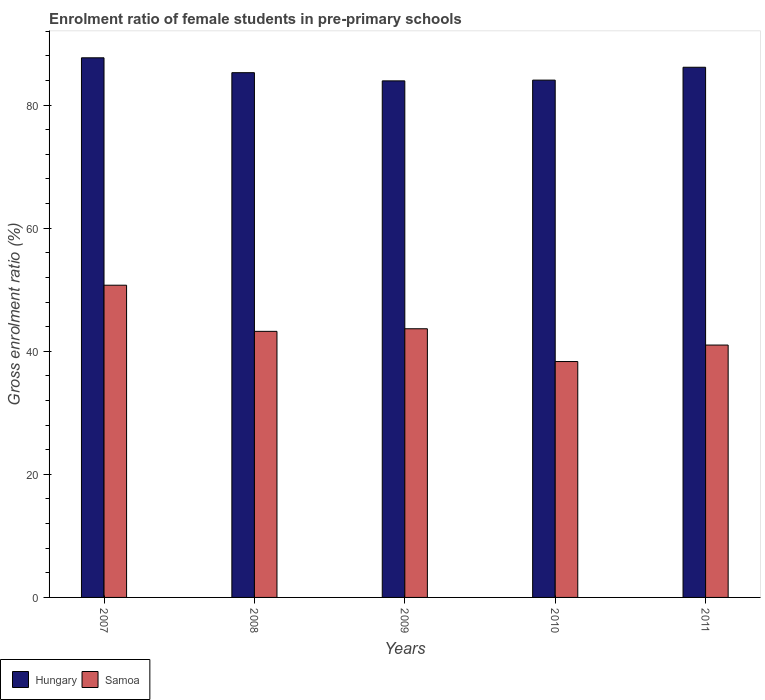How many different coloured bars are there?
Provide a short and direct response. 2. Are the number of bars on each tick of the X-axis equal?
Provide a succinct answer. Yes. In how many cases, is the number of bars for a given year not equal to the number of legend labels?
Ensure brevity in your answer.  0. What is the enrolment ratio of female students in pre-primary schools in Hungary in 2009?
Provide a short and direct response. 83.95. Across all years, what is the maximum enrolment ratio of female students in pre-primary schools in Hungary?
Your answer should be compact. 87.69. Across all years, what is the minimum enrolment ratio of female students in pre-primary schools in Samoa?
Your answer should be very brief. 38.33. What is the total enrolment ratio of female students in pre-primary schools in Hungary in the graph?
Your answer should be very brief. 427.15. What is the difference between the enrolment ratio of female students in pre-primary schools in Hungary in 2007 and that in 2009?
Your response must be concise. 3.75. What is the difference between the enrolment ratio of female students in pre-primary schools in Hungary in 2008 and the enrolment ratio of female students in pre-primary schools in Samoa in 2009?
Offer a terse response. 41.62. What is the average enrolment ratio of female students in pre-primary schools in Hungary per year?
Your answer should be very brief. 85.43. In the year 2011, what is the difference between the enrolment ratio of female students in pre-primary schools in Samoa and enrolment ratio of female students in pre-primary schools in Hungary?
Give a very brief answer. -45.15. What is the ratio of the enrolment ratio of female students in pre-primary schools in Samoa in 2008 to that in 2009?
Make the answer very short. 0.99. What is the difference between the highest and the second highest enrolment ratio of female students in pre-primary schools in Hungary?
Your response must be concise. 1.53. What is the difference between the highest and the lowest enrolment ratio of female students in pre-primary schools in Hungary?
Offer a very short reply. 3.75. What does the 2nd bar from the left in 2010 represents?
Offer a very short reply. Samoa. What does the 2nd bar from the right in 2011 represents?
Your answer should be compact. Hungary. How many bars are there?
Your answer should be very brief. 10. What is the difference between two consecutive major ticks on the Y-axis?
Provide a short and direct response. 20. Does the graph contain any zero values?
Offer a very short reply. No. Does the graph contain grids?
Your answer should be very brief. No. Where does the legend appear in the graph?
Provide a short and direct response. Bottom left. How many legend labels are there?
Provide a succinct answer. 2. How are the legend labels stacked?
Give a very brief answer. Horizontal. What is the title of the graph?
Provide a succinct answer. Enrolment ratio of female students in pre-primary schools. Does "Korea (Republic)" appear as one of the legend labels in the graph?
Your answer should be compact. No. What is the label or title of the X-axis?
Your response must be concise. Years. What is the label or title of the Y-axis?
Provide a succinct answer. Gross enrolment ratio (%). What is the Gross enrolment ratio (%) in Hungary in 2007?
Offer a terse response. 87.69. What is the Gross enrolment ratio (%) of Samoa in 2007?
Ensure brevity in your answer.  50.74. What is the Gross enrolment ratio (%) of Hungary in 2008?
Provide a succinct answer. 85.28. What is the Gross enrolment ratio (%) in Samoa in 2008?
Provide a short and direct response. 43.24. What is the Gross enrolment ratio (%) of Hungary in 2009?
Provide a succinct answer. 83.95. What is the Gross enrolment ratio (%) of Samoa in 2009?
Provide a short and direct response. 43.66. What is the Gross enrolment ratio (%) of Hungary in 2010?
Offer a very short reply. 84.07. What is the Gross enrolment ratio (%) in Samoa in 2010?
Offer a very short reply. 38.33. What is the Gross enrolment ratio (%) of Hungary in 2011?
Give a very brief answer. 86.16. What is the Gross enrolment ratio (%) of Samoa in 2011?
Offer a terse response. 41.01. Across all years, what is the maximum Gross enrolment ratio (%) of Hungary?
Make the answer very short. 87.69. Across all years, what is the maximum Gross enrolment ratio (%) in Samoa?
Your answer should be very brief. 50.74. Across all years, what is the minimum Gross enrolment ratio (%) of Hungary?
Provide a short and direct response. 83.95. Across all years, what is the minimum Gross enrolment ratio (%) in Samoa?
Offer a very short reply. 38.33. What is the total Gross enrolment ratio (%) of Hungary in the graph?
Give a very brief answer. 427.15. What is the total Gross enrolment ratio (%) in Samoa in the graph?
Offer a very short reply. 216.98. What is the difference between the Gross enrolment ratio (%) of Hungary in 2007 and that in 2008?
Your answer should be very brief. 2.42. What is the difference between the Gross enrolment ratio (%) of Samoa in 2007 and that in 2008?
Ensure brevity in your answer.  7.5. What is the difference between the Gross enrolment ratio (%) of Hungary in 2007 and that in 2009?
Your answer should be compact. 3.75. What is the difference between the Gross enrolment ratio (%) in Samoa in 2007 and that in 2009?
Offer a very short reply. 7.08. What is the difference between the Gross enrolment ratio (%) in Hungary in 2007 and that in 2010?
Your answer should be very brief. 3.63. What is the difference between the Gross enrolment ratio (%) of Samoa in 2007 and that in 2010?
Offer a terse response. 12.4. What is the difference between the Gross enrolment ratio (%) of Hungary in 2007 and that in 2011?
Ensure brevity in your answer.  1.53. What is the difference between the Gross enrolment ratio (%) of Samoa in 2007 and that in 2011?
Keep it short and to the point. 9.72. What is the difference between the Gross enrolment ratio (%) in Hungary in 2008 and that in 2009?
Give a very brief answer. 1.33. What is the difference between the Gross enrolment ratio (%) in Samoa in 2008 and that in 2009?
Provide a succinct answer. -0.42. What is the difference between the Gross enrolment ratio (%) of Hungary in 2008 and that in 2010?
Ensure brevity in your answer.  1.21. What is the difference between the Gross enrolment ratio (%) of Samoa in 2008 and that in 2010?
Provide a succinct answer. 4.91. What is the difference between the Gross enrolment ratio (%) in Hungary in 2008 and that in 2011?
Your answer should be compact. -0.88. What is the difference between the Gross enrolment ratio (%) in Samoa in 2008 and that in 2011?
Keep it short and to the point. 2.23. What is the difference between the Gross enrolment ratio (%) of Hungary in 2009 and that in 2010?
Offer a very short reply. -0.12. What is the difference between the Gross enrolment ratio (%) of Samoa in 2009 and that in 2010?
Offer a very short reply. 5.33. What is the difference between the Gross enrolment ratio (%) in Hungary in 2009 and that in 2011?
Your answer should be very brief. -2.21. What is the difference between the Gross enrolment ratio (%) of Samoa in 2009 and that in 2011?
Make the answer very short. 2.65. What is the difference between the Gross enrolment ratio (%) in Hungary in 2010 and that in 2011?
Ensure brevity in your answer.  -2.09. What is the difference between the Gross enrolment ratio (%) of Samoa in 2010 and that in 2011?
Your response must be concise. -2.68. What is the difference between the Gross enrolment ratio (%) of Hungary in 2007 and the Gross enrolment ratio (%) of Samoa in 2008?
Give a very brief answer. 44.46. What is the difference between the Gross enrolment ratio (%) in Hungary in 2007 and the Gross enrolment ratio (%) in Samoa in 2009?
Your answer should be very brief. 44.03. What is the difference between the Gross enrolment ratio (%) in Hungary in 2007 and the Gross enrolment ratio (%) in Samoa in 2010?
Your response must be concise. 49.36. What is the difference between the Gross enrolment ratio (%) of Hungary in 2007 and the Gross enrolment ratio (%) of Samoa in 2011?
Give a very brief answer. 46.68. What is the difference between the Gross enrolment ratio (%) of Hungary in 2008 and the Gross enrolment ratio (%) of Samoa in 2009?
Keep it short and to the point. 41.62. What is the difference between the Gross enrolment ratio (%) in Hungary in 2008 and the Gross enrolment ratio (%) in Samoa in 2010?
Keep it short and to the point. 46.94. What is the difference between the Gross enrolment ratio (%) in Hungary in 2008 and the Gross enrolment ratio (%) in Samoa in 2011?
Your answer should be compact. 44.26. What is the difference between the Gross enrolment ratio (%) in Hungary in 2009 and the Gross enrolment ratio (%) in Samoa in 2010?
Your answer should be compact. 45.61. What is the difference between the Gross enrolment ratio (%) in Hungary in 2009 and the Gross enrolment ratio (%) in Samoa in 2011?
Ensure brevity in your answer.  42.93. What is the difference between the Gross enrolment ratio (%) of Hungary in 2010 and the Gross enrolment ratio (%) of Samoa in 2011?
Provide a short and direct response. 43.06. What is the average Gross enrolment ratio (%) in Hungary per year?
Your answer should be compact. 85.43. What is the average Gross enrolment ratio (%) of Samoa per year?
Provide a succinct answer. 43.4. In the year 2007, what is the difference between the Gross enrolment ratio (%) of Hungary and Gross enrolment ratio (%) of Samoa?
Your answer should be very brief. 36.96. In the year 2008, what is the difference between the Gross enrolment ratio (%) of Hungary and Gross enrolment ratio (%) of Samoa?
Offer a very short reply. 42.04. In the year 2009, what is the difference between the Gross enrolment ratio (%) in Hungary and Gross enrolment ratio (%) in Samoa?
Your response must be concise. 40.29. In the year 2010, what is the difference between the Gross enrolment ratio (%) in Hungary and Gross enrolment ratio (%) in Samoa?
Provide a short and direct response. 45.73. In the year 2011, what is the difference between the Gross enrolment ratio (%) of Hungary and Gross enrolment ratio (%) of Samoa?
Give a very brief answer. 45.15. What is the ratio of the Gross enrolment ratio (%) in Hungary in 2007 to that in 2008?
Your answer should be very brief. 1.03. What is the ratio of the Gross enrolment ratio (%) of Samoa in 2007 to that in 2008?
Keep it short and to the point. 1.17. What is the ratio of the Gross enrolment ratio (%) of Hungary in 2007 to that in 2009?
Make the answer very short. 1.04. What is the ratio of the Gross enrolment ratio (%) of Samoa in 2007 to that in 2009?
Your answer should be compact. 1.16. What is the ratio of the Gross enrolment ratio (%) in Hungary in 2007 to that in 2010?
Provide a short and direct response. 1.04. What is the ratio of the Gross enrolment ratio (%) of Samoa in 2007 to that in 2010?
Your answer should be compact. 1.32. What is the ratio of the Gross enrolment ratio (%) of Hungary in 2007 to that in 2011?
Your answer should be compact. 1.02. What is the ratio of the Gross enrolment ratio (%) of Samoa in 2007 to that in 2011?
Your answer should be very brief. 1.24. What is the ratio of the Gross enrolment ratio (%) in Hungary in 2008 to that in 2009?
Offer a very short reply. 1.02. What is the ratio of the Gross enrolment ratio (%) in Samoa in 2008 to that in 2009?
Provide a short and direct response. 0.99. What is the ratio of the Gross enrolment ratio (%) in Hungary in 2008 to that in 2010?
Make the answer very short. 1.01. What is the ratio of the Gross enrolment ratio (%) of Samoa in 2008 to that in 2010?
Your answer should be compact. 1.13. What is the ratio of the Gross enrolment ratio (%) of Hungary in 2008 to that in 2011?
Give a very brief answer. 0.99. What is the ratio of the Gross enrolment ratio (%) of Samoa in 2008 to that in 2011?
Give a very brief answer. 1.05. What is the ratio of the Gross enrolment ratio (%) in Hungary in 2009 to that in 2010?
Make the answer very short. 1. What is the ratio of the Gross enrolment ratio (%) of Samoa in 2009 to that in 2010?
Your response must be concise. 1.14. What is the ratio of the Gross enrolment ratio (%) of Hungary in 2009 to that in 2011?
Your response must be concise. 0.97. What is the ratio of the Gross enrolment ratio (%) in Samoa in 2009 to that in 2011?
Ensure brevity in your answer.  1.06. What is the ratio of the Gross enrolment ratio (%) in Hungary in 2010 to that in 2011?
Offer a terse response. 0.98. What is the ratio of the Gross enrolment ratio (%) in Samoa in 2010 to that in 2011?
Keep it short and to the point. 0.93. What is the difference between the highest and the second highest Gross enrolment ratio (%) in Hungary?
Ensure brevity in your answer.  1.53. What is the difference between the highest and the second highest Gross enrolment ratio (%) of Samoa?
Provide a succinct answer. 7.08. What is the difference between the highest and the lowest Gross enrolment ratio (%) of Hungary?
Provide a short and direct response. 3.75. What is the difference between the highest and the lowest Gross enrolment ratio (%) in Samoa?
Give a very brief answer. 12.4. 